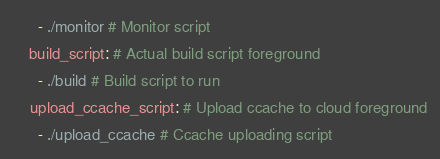<code> <loc_0><loc_0><loc_500><loc_500><_YAML_>      - ./monitor # Monitor script
    build_script: # Actual build script foreground
      - ./build # Build script to run
    upload_ccache_script: # Upload ccache to cloud foreground
      - ./upload_ccache # Ccache uploading script
</code> 